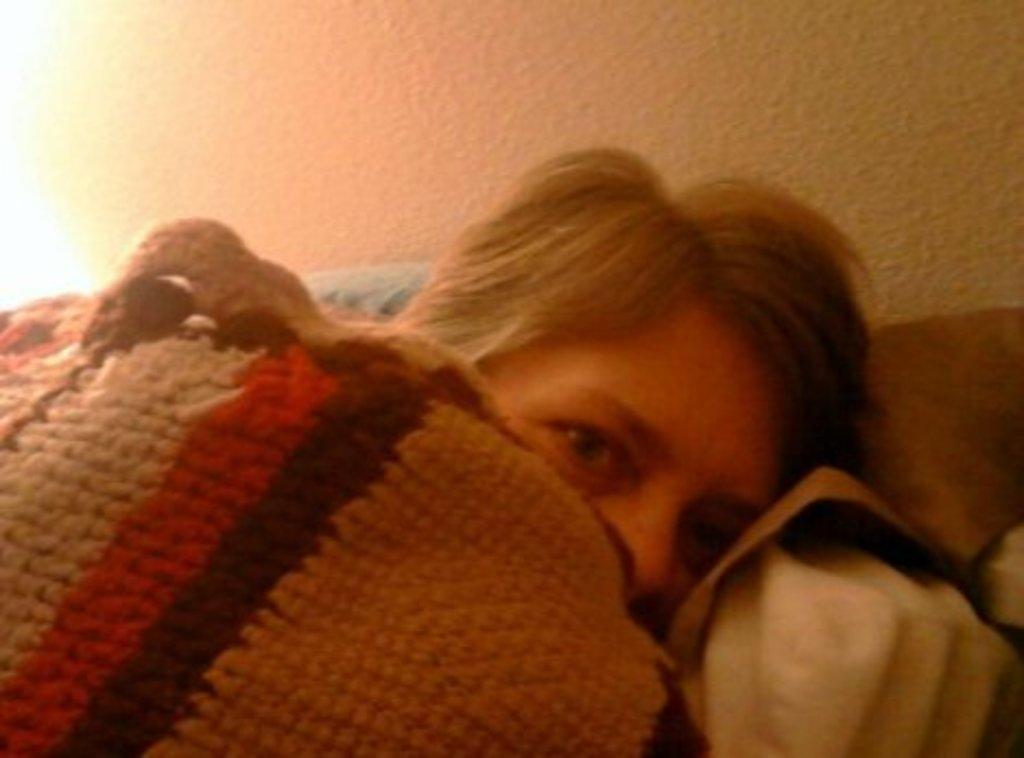What is the person in the image doing? The person is lying down in the image. What is the person holding while lying down? The person is holding a blanket. What can be seen in the background of the image? There is a wall visible in the background of the image. What type of lettuce is being used as a pillow in the image? There is no lettuce present in the image; the person is holding a blanket while lying down. 